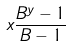<formula> <loc_0><loc_0><loc_500><loc_500>x \frac { B ^ { y } - 1 } { B - 1 }</formula> 